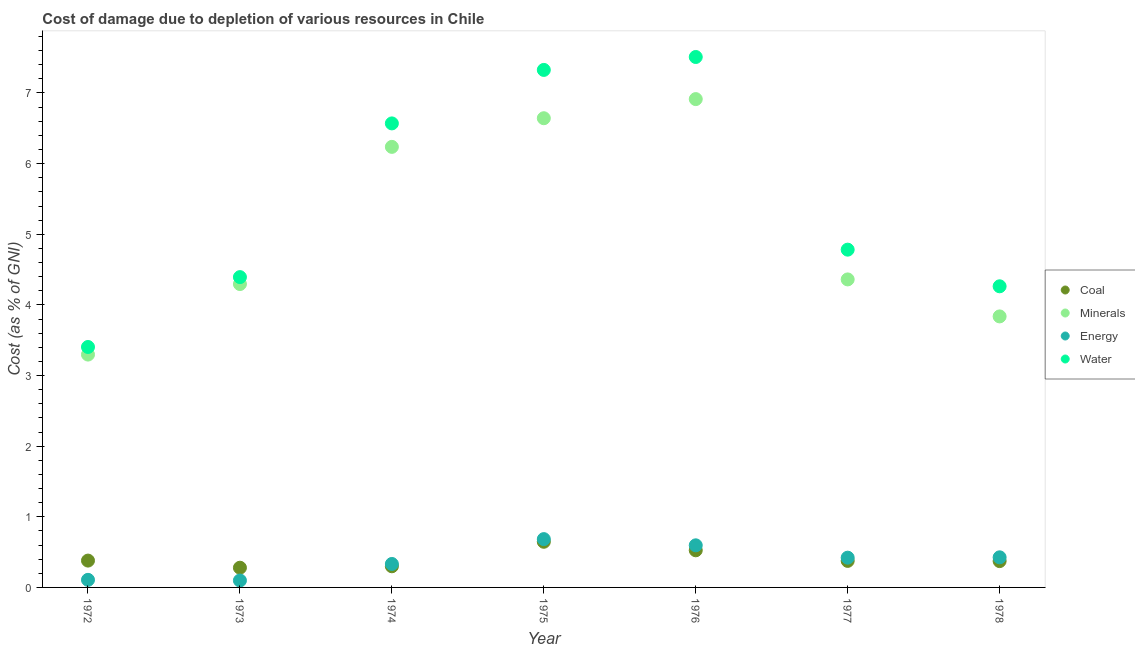How many different coloured dotlines are there?
Your answer should be very brief. 4. Is the number of dotlines equal to the number of legend labels?
Your answer should be compact. Yes. What is the cost of damage due to depletion of coal in 1972?
Provide a succinct answer. 0.38. Across all years, what is the maximum cost of damage due to depletion of coal?
Your answer should be compact. 0.65. Across all years, what is the minimum cost of damage due to depletion of energy?
Keep it short and to the point. 0.1. In which year was the cost of damage due to depletion of coal maximum?
Keep it short and to the point. 1975. In which year was the cost of damage due to depletion of energy minimum?
Keep it short and to the point. 1973. What is the total cost of damage due to depletion of coal in the graph?
Ensure brevity in your answer.  2.88. What is the difference between the cost of damage due to depletion of energy in 1973 and that in 1974?
Provide a succinct answer. -0.23. What is the difference between the cost of damage due to depletion of water in 1975 and the cost of damage due to depletion of coal in 1977?
Ensure brevity in your answer.  6.95. What is the average cost of damage due to depletion of energy per year?
Give a very brief answer. 0.38. In the year 1976, what is the difference between the cost of damage due to depletion of coal and cost of damage due to depletion of minerals?
Your answer should be very brief. -6.39. What is the ratio of the cost of damage due to depletion of coal in 1975 to that in 1978?
Your answer should be compact. 1.73. Is the cost of damage due to depletion of minerals in 1974 less than that in 1977?
Make the answer very short. No. Is the difference between the cost of damage due to depletion of minerals in 1975 and 1977 greater than the difference between the cost of damage due to depletion of water in 1975 and 1977?
Give a very brief answer. No. What is the difference between the highest and the second highest cost of damage due to depletion of energy?
Give a very brief answer. 0.09. What is the difference between the highest and the lowest cost of damage due to depletion of coal?
Provide a succinct answer. 0.37. In how many years, is the cost of damage due to depletion of water greater than the average cost of damage due to depletion of water taken over all years?
Your response must be concise. 3. Is the sum of the cost of damage due to depletion of minerals in 1974 and 1976 greater than the maximum cost of damage due to depletion of water across all years?
Provide a short and direct response. Yes. Is it the case that in every year, the sum of the cost of damage due to depletion of energy and cost of damage due to depletion of water is greater than the sum of cost of damage due to depletion of coal and cost of damage due to depletion of minerals?
Ensure brevity in your answer.  No. Is it the case that in every year, the sum of the cost of damage due to depletion of coal and cost of damage due to depletion of minerals is greater than the cost of damage due to depletion of energy?
Your answer should be very brief. Yes. Is the cost of damage due to depletion of water strictly less than the cost of damage due to depletion of coal over the years?
Keep it short and to the point. No. What is the difference between two consecutive major ticks on the Y-axis?
Offer a terse response. 1. Are the values on the major ticks of Y-axis written in scientific E-notation?
Make the answer very short. No. Does the graph contain any zero values?
Ensure brevity in your answer.  No. How are the legend labels stacked?
Your answer should be compact. Vertical. What is the title of the graph?
Provide a succinct answer. Cost of damage due to depletion of various resources in Chile . Does "Secondary general education" appear as one of the legend labels in the graph?
Keep it short and to the point. No. What is the label or title of the X-axis?
Offer a terse response. Year. What is the label or title of the Y-axis?
Your answer should be very brief. Cost (as % of GNI). What is the Cost (as % of GNI) in Coal in 1972?
Provide a short and direct response. 0.38. What is the Cost (as % of GNI) of Minerals in 1972?
Ensure brevity in your answer.  3.3. What is the Cost (as % of GNI) of Energy in 1972?
Make the answer very short. 0.11. What is the Cost (as % of GNI) of Water in 1972?
Your answer should be compact. 3.4. What is the Cost (as % of GNI) of Coal in 1973?
Give a very brief answer. 0.28. What is the Cost (as % of GNI) in Minerals in 1973?
Your response must be concise. 4.3. What is the Cost (as % of GNI) in Energy in 1973?
Give a very brief answer. 0.1. What is the Cost (as % of GNI) in Water in 1973?
Ensure brevity in your answer.  4.39. What is the Cost (as % of GNI) in Coal in 1974?
Your answer should be very brief. 0.3. What is the Cost (as % of GNI) in Minerals in 1974?
Your answer should be very brief. 6.24. What is the Cost (as % of GNI) in Energy in 1974?
Ensure brevity in your answer.  0.33. What is the Cost (as % of GNI) in Water in 1974?
Offer a very short reply. 6.57. What is the Cost (as % of GNI) of Coal in 1975?
Your response must be concise. 0.65. What is the Cost (as % of GNI) of Minerals in 1975?
Offer a very short reply. 6.64. What is the Cost (as % of GNI) of Energy in 1975?
Offer a terse response. 0.68. What is the Cost (as % of GNI) of Water in 1975?
Provide a short and direct response. 7.33. What is the Cost (as % of GNI) in Coal in 1976?
Provide a succinct answer. 0.53. What is the Cost (as % of GNI) of Minerals in 1976?
Ensure brevity in your answer.  6.91. What is the Cost (as % of GNI) in Energy in 1976?
Make the answer very short. 0.6. What is the Cost (as % of GNI) in Water in 1976?
Give a very brief answer. 7.51. What is the Cost (as % of GNI) of Coal in 1977?
Your response must be concise. 0.38. What is the Cost (as % of GNI) of Minerals in 1977?
Keep it short and to the point. 4.36. What is the Cost (as % of GNI) of Energy in 1977?
Offer a terse response. 0.42. What is the Cost (as % of GNI) in Water in 1977?
Your answer should be very brief. 4.78. What is the Cost (as % of GNI) of Coal in 1978?
Provide a succinct answer. 0.37. What is the Cost (as % of GNI) in Minerals in 1978?
Your response must be concise. 3.84. What is the Cost (as % of GNI) of Energy in 1978?
Provide a short and direct response. 0.43. What is the Cost (as % of GNI) of Water in 1978?
Your response must be concise. 4.26. Across all years, what is the maximum Cost (as % of GNI) in Coal?
Offer a very short reply. 0.65. Across all years, what is the maximum Cost (as % of GNI) in Minerals?
Offer a terse response. 6.91. Across all years, what is the maximum Cost (as % of GNI) in Energy?
Provide a succinct answer. 0.68. Across all years, what is the maximum Cost (as % of GNI) in Water?
Your answer should be compact. 7.51. Across all years, what is the minimum Cost (as % of GNI) of Coal?
Give a very brief answer. 0.28. Across all years, what is the minimum Cost (as % of GNI) in Minerals?
Offer a terse response. 3.3. Across all years, what is the minimum Cost (as % of GNI) in Energy?
Give a very brief answer. 0.1. Across all years, what is the minimum Cost (as % of GNI) of Water?
Make the answer very short. 3.4. What is the total Cost (as % of GNI) in Coal in the graph?
Keep it short and to the point. 2.88. What is the total Cost (as % of GNI) in Minerals in the graph?
Make the answer very short. 35.58. What is the total Cost (as % of GNI) of Energy in the graph?
Give a very brief answer. 2.67. What is the total Cost (as % of GNI) in Water in the graph?
Keep it short and to the point. 38.25. What is the difference between the Cost (as % of GNI) in Coal in 1972 and that in 1973?
Provide a succinct answer. 0.1. What is the difference between the Cost (as % of GNI) in Minerals in 1972 and that in 1973?
Give a very brief answer. -1. What is the difference between the Cost (as % of GNI) of Energy in 1972 and that in 1973?
Give a very brief answer. 0.01. What is the difference between the Cost (as % of GNI) of Water in 1972 and that in 1973?
Offer a terse response. -0.99. What is the difference between the Cost (as % of GNI) of Coal in 1972 and that in 1974?
Offer a very short reply. 0.08. What is the difference between the Cost (as % of GNI) of Minerals in 1972 and that in 1974?
Your response must be concise. -2.94. What is the difference between the Cost (as % of GNI) in Energy in 1972 and that in 1974?
Give a very brief answer. -0.22. What is the difference between the Cost (as % of GNI) in Water in 1972 and that in 1974?
Keep it short and to the point. -3.17. What is the difference between the Cost (as % of GNI) in Coal in 1972 and that in 1975?
Provide a short and direct response. -0.27. What is the difference between the Cost (as % of GNI) in Minerals in 1972 and that in 1975?
Your response must be concise. -3.35. What is the difference between the Cost (as % of GNI) in Energy in 1972 and that in 1975?
Your answer should be very brief. -0.58. What is the difference between the Cost (as % of GNI) of Water in 1972 and that in 1975?
Offer a very short reply. -3.92. What is the difference between the Cost (as % of GNI) of Coal in 1972 and that in 1976?
Give a very brief answer. -0.15. What is the difference between the Cost (as % of GNI) in Minerals in 1972 and that in 1976?
Offer a terse response. -3.62. What is the difference between the Cost (as % of GNI) of Energy in 1972 and that in 1976?
Provide a succinct answer. -0.49. What is the difference between the Cost (as % of GNI) of Water in 1972 and that in 1976?
Your answer should be very brief. -4.11. What is the difference between the Cost (as % of GNI) of Coal in 1972 and that in 1977?
Your response must be concise. 0. What is the difference between the Cost (as % of GNI) in Minerals in 1972 and that in 1977?
Your response must be concise. -1.06. What is the difference between the Cost (as % of GNI) of Energy in 1972 and that in 1977?
Your answer should be compact. -0.31. What is the difference between the Cost (as % of GNI) in Water in 1972 and that in 1977?
Offer a very short reply. -1.38. What is the difference between the Cost (as % of GNI) in Coal in 1972 and that in 1978?
Provide a short and direct response. 0.01. What is the difference between the Cost (as % of GNI) in Minerals in 1972 and that in 1978?
Give a very brief answer. -0.54. What is the difference between the Cost (as % of GNI) in Energy in 1972 and that in 1978?
Provide a succinct answer. -0.32. What is the difference between the Cost (as % of GNI) in Water in 1972 and that in 1978?
Offer a very short reply. -0.86. What is the difference between the Cost (as % of GNI) of Coal in 1973 and that in 1974?
Give a very brief answer. -0.02. What is the difference between the Cost (as % of GNI) of Minerals in 1973 and that in 1974?
Your answer should be compact. -1.94. What is the difference between the Cost (as % of GNI) in Energy in 1973 and that in 1974?
Provide a succinct answer. -0.23. What is the difference between the Cost (as % of GNI) in Water in 1973 and that in 1974?
Your answer should be very brief. -2.18. What is the difference between the Cost (as % of GNI) in Coal in 1973 and that in 1975?
Make the answer very short. -0.37. What is the difference between the Cost (as % of GNI) of Minerals in 1973 and that in 1975?
Your answer should be compact. -2.35. What is the difference between the Cost (as % of GNI) of Energy in 1973 and that in 1975?
Make the answer very short. -0.59. What is the difference between the Cost (as % of GNI) in Water in 1973 and that in 1975?
Your response must be concise. -2.93. What is the difference between the Cost (as % of GNI) in Coal in 1973 and that in 1976?
Provide a succinct answer. -0.25. What is the difference between the Cost (as % of GNI) in Minerals in 1973 and that in 1976?
Ensure brevity in your answer.  -2.62. What is the difference between the Cost (as % of GNI) of Energy in 1973 and that in 1976?
Provide a short and direct response. -0.5. What is the difference between the Cost (as % of GNI) in Water in 1973 and that in 1976?
Offer a very short reply. -3.12. What is the difference between the Cost (as % of GNI) of Coal in 1973 and that in 1977?
Ensure brevity in your answer.  -0.1. What is the difference between the Cost (as % of GNI) of Minerals in 1973 and that in 1977?
Ensure brevity in your answer.  -0.07. What is the difference between the Cost (as % of GNI) of Energy in 1973 and that in 1977?
Give a very brief answer. -0.32. What is the difference between the Cost (as % of GNI) in Water in 1973 and that in 1977?
Keep it short and to the point. -0.39. What is the difference between the Cost (as % of GNI) in Coal in 1973 and that in 1978?
Your answer should be very brief. -0.09. What is the difference between the Cost (as % of GNI) of Minerals in 1973 and that in 1978?
Your response must be concise. 0.46. What is the difference between the Cost (as % of GNI) in Energy in 1973 and that in 1978?
Your answer should be compact. -0.33. What is the difference between the Cost (as % of GNI) in Water in 1973 and that in 1978?
Give a very brief answer. 0.13. What is the difference between the Cost (as % of GNI) of Coal in 1974 and that in 1975?
Offer a terse response. -0.35. What is the difference between the Cost (as % of GNI) of Minerals in 1974 and that in 1975?
Keep it short and to the point. -0.41. What is the difference between the Cost (as % of GNI) of Energy in 1974 and that in 1975?
Provide a short and direct response. -0.35. What is the difference between the Cost (as % of GNI) of Water in 1974 and that in 1975?
Keep it short and to the point. -0.76. What is the difference between the Cost (as % of GNI) of Coal in 1974 and that in 1976?
Ensure brevity in your answer.  -0.23. What is the difference between the Cost (as % of GNI) of Minerals in 1974 and that in 1976?
Give a very brief answer. -0.68. What is the difference between the Cost (as % of GNI) in Energy in 1974 and that in 1976?
Ensure brevity in your answer.  -0.26. What is the difference between the Cost (as % of GNI) of Water in 1974 and that in 1976?
Keep it short and to the point. -0.94. What is the difference between the Cost (as % of GNI) of Coal in 1974 and that in 1977?
Make the answer very short. -0.08. What is the difference between the Cost (as % of GNI) in Minerals in 1974 and that in 1977?
Provide a short and direct response. 1.88. What is the difference between the Cost (as % of GNI) of Energy in 1974 and that in 1977?
Your answer should be compact. -0.09. What is the difference between the Cost (as % of GNI) in Water in 1974 and that in 1977?
Your answer should be compact. 1.79. What is the difference between the Cost (as % of GNI) of Coal in 1974 and that in 1978?
Offer a very short reply. -0.07. What is the difference between the Cost (as % of GNI) of Minerals in 1974 and that in 1978?
Ensure brevity in your answer.  2.4. What is the difference between the Cost (as % of GNI) of Energy in 1974 and that in 1978?
Your answer should be very brief. -0.09. What is the difference between the Cost (as % of GNI) in Water in 1974 and that in 1978?
Keep it short and to the point. 2.31. What is the difference between the Cost (as % of GNI) in Coal in 1975 and that in 1976?
Your answer should be compact. 0.12. What is the difference between the Cost (as % of GNI) in Minerals in 1975 and that in 1976?
Give a very brief answer. -0.27. What is the difference between the Cost (as % of GNI) in Energy in 1975 and that in 1976?
Give a very brief answer. 0.09. What is the difference between the Cost (as % of GNI) of Water in 1975 and that in 1976?
Your response must be concise. -0.18. What is the difference between the Cost (as % of GNI) of Coal in 1975 and that in 1977?
Your answer should be very brief. 0.27. What is the difference between the Cost (as % of GNI) of Minerals in 1975 and that in 1977?
Provide a succinct answer. 2.28. What is the difference between the Cost (as % of GNI) of Energy in 1975 and that in 1977?
Provide a short and direct response. 0.26. What is the difference between the Cost (as % of GNI) in Water in 1975 and that in 1977?
Make the answer very short. 2.54. What is the difference between the Cost (as % of GNI) of Coal in 1975 and that in 1978?
Offer a terse response. 0.27. What is the difference between the Cost (as % of GNI) of Minerals in 1975 and that in 1978?
Give a very brief answer. 2.81. What is the difference between the Cost (as % of GNI) of Energy in 1975 and that in 1978?
Provide a succinct answer. 0.26. What is the difference between the Cost (as % of GNI) in Water in 1975 and that in 1978?
Provide a short and direct response. 3.06. What is the difference between the Cost (as % of GNI) of Coal in 1976 and that in 1977?
Offer a terse response. 0.15. What is the difference between the Cost (as % of GNI) of Minerals in 1976 and that in 1977?
Make the answer very short. 2.55. What is the difference between the Cost (as % of GNI) in Energy in 1976 and that in 1977?
Provide a succinct answer. 0.17. What is the difference between the Cost (as % of GNI) in Water in 1976 and that in 1977?
Offer a terse response. 2.73. What is the difference between the Cost (as % of GNI) in Coal in 1976 and that in 1978?
Offer a very short reply. 0.15. What is the difference between the Cost (as % of GNI) in Minerals in 1976 and that in 1978?
Keep it short and to the point. 3.08. What is the difference between the Cost (as % of GNI) in Energy in 1976 and that in 1978?
Make the answer very short. 0.17. What is the difference between the Cost (as % of GNI) in Water in 1976 and that in 1978?
Give a very brief answer. 3.25. What is the difference between the Cost (as % of GNI) of Coal in 1977 and that in 1978?
Your answer should be compact. 0. What is the difference between the Cost (as % of GNI) of Minerals in 1977 and that in 1978?
Your answer should be compact. 0.52. What is the difference between the Cost (as % of GNI) of Energy in 1977 and that in 1978?
Your answer should be very brief. -0.01. What is the difference between the Cost (as % of GNI) of Water in 1977 and that in 1978?
Give a very brief answer. 0.52. What is the difference between the Cost (as % of GNI) of Coal in 1972 and the Cost (as % of GNI) of Minerals in 1973?
Your response must be concise. -3.92. What is the difference between the Cost (as % of GNI) of Coal in 1972 and the Cost (as % of GNI) of Energy in 1973?
Provide a succinct answer. 0.28. What is the difference between the Cost (as % of GNI) of Coal in 1972 and the Cost (as % of GNI) of Water in 1973?
Provide a succinct answer. -4.01. What is the difference between the Cost (as % of GNI) in Minerals in 1972 and the Cost (as % of GNI) in Energy in 1973?
Your answer should be compact. 3.2. What is the difference between the Cost (as % of GNI) in Minerals in 1972 and the Cost (as % of GNI) in Water in 1973?
Provide a succinct answer. -1.1. What is the difference between the Cost (as % of GNI) in Energy in 1972 and the Cost (as % of GNI) in Water in 1973?
Your answer should be compact. -4.29. What is the difference between the Cost (as % of GNI) of Coal in 1972 and the Cost (as % of GNI) of Minerals in 1974?
Your answer should be compact. -5.86. What is the difference between the Cost (as % of GNI) of Coal in 1972 and the Cost (as % of GNI) of Energy in 1974?
Ensure brevity in your answer.  0.05. What is the difference between the Cost (as % of GNI) in Coal in 1972 and the Cost (as % of GNI) in Water in 1974?
Offer a very short reply. -6.19. What is the difference between the Cost (as % of GNI) in Minerals in 1972 and the Cost (as % of GNI) in Energy in 1974?
Give a very brief answer. 2.96. What is the difference between the Cost (as % of GNI) in Minerals in 1972 and the Cost (as % of GNI) in Water in 1974?
Your response must be concise. -3.27. What is the difference between the Cost (as % of GNI) in Energy in 1972 and the Cost (as % of GNI) in Water in 1974?
Offer a terse response. -6.46. What is the difference between the Cost (as % of GNI) of Coal in 1972 and the Cost (as % of GNI) of Minerals in 1975?
Offer a very short reply. -6.26. What is the difference between the Cost (as % of GNI) in Coal in 1972 and the Cost (as % of GNI) in Energy in 1975?
Your answer should be compact. -0.3. What is the difference between the Cost (as % of GNI) in Coal in 1972 and the Cost (as % of GNI) in Water in 1975?
Your answer should be compact. -6.95. What is the difference between the Cost (as % of GNI) of Minerals in 1972 and the Cost (as % of GNI) of Energy in 1975?
Offer a very short reply. 2.61. What is the difference between the Cost (as % of GNI) in Minerals in 1972 and the Cost (as % of GNI) in Water in 1975?
Offer a very short reply. -4.03. What is the difference between the Cost (as % of GNI) in Energy in 1972 and the Cost (as % of GNI) in Water in 1975?
Offer a terse response. -7.22. What is the difference between the Cost (as % of GNI) of Coal in 1972 and the Cost (as % of GNI) of Minerals in 1976?
Keep it short and to the point. -6.53. What is the difference between the Cost (as % of GNI) of Coal in 1972 and the Cost (as % of GNI) of Energy in 1976?
Provide a short and direct response. -0.22. What is the difference between the Cost (as % of GNI) in Coal in 1972 and the Cost (as % of GNI) in Water in 1976?
Your answer should be compact. -7.13. What is the difference between the Cost (as % of GNI) in Minerals in 1972 and the Cost (as % of GNI) in Energy in 1976?
Your answer should be very brief. 2.7. What is the difference between the Cost (as % of GNI) in Minerals in 1972 and the Cost (as % of GNI) in Water in 1976?
Offer a terse response. -4.21. What is the difference between the Cost (as % of GNI) in Energy in 1972 and the Cost (as % of GNI) in Water in 1976?
Your answer should be compact. -7.4. What is the difference between the Cost (as % of GNI) in Coal in 1972 and the Cost (as % of GNI) in Minerals in 1977?
Provide a short and direct response. -3.98. What is the difference between the Cost (as % of GNI) in Coal in 1972 and the Cost (as % of GNI) in Energy in 1977?
Keep it short and to the point. -0.04. What is the difference between the Cost (as % of GNI) in Coal in 1972 and the Cost (as % of GNI) in Water in 1977?
Your response must be concise. -4.4. What is the difference between the Cost (as % of GNI) of Minerals in 1972 and the Cost (as % of GNI) of Energy in 1977?
Make the answer very short. 2.88. What is the difference between the Cost (as % of GNI) in Minerals in 1972 and the Cost (as % of GNI) in Water in 1977?
Make the answer very short. -1.49. What is the difference between the Cost (as % of GNI) of Energy in 1972 and the Cost (as % of GNI) of Water in 1977?
Keep it short and to the point. -4.67. What is the difference between the Cost (as % of GNI) in Coal in 1972 and the Cost (as % of GNI) in Minerals in 1978?
Your answer should be compact. -3.46. What is the difference between the Cost (as % of GNI) in Coal in 1972 and the Cost (as % of GNI) in Energy in 1978?
Give a very brief answer. -0.05. What is the difference between the Cost (as % of GNI) of Coal in 1972 and the Cost (as % of GNI) of Water in 1978?
Make the answer very short. -3.88. What is the difference between the Cost (as % of GNI) of Minerals in 1972 and the Cost (as % of GNI) of Energy in 1978?
Give a very brief answer. 2.87. What is the difference between the Cost (as % of GNI) in Minerals in 1972 and the Cost (as % of GNI) in Water in 1978?
Ensure brevity in your answer.  -0.97. What is the difference between the Cost (as % of GNI) in Energy in 1972 and the Cost (as % of GNI) in Water in 1978?
Your response must be concise. -4.16. What is the difference between the Cost (as % of GNI) in Coal in 1973 and the Cost (as % of GNI) in Minerals in 1974?
Make the answer very short. -5.96. What is the difference between the Cost (as % of GNI) in Coal in 1973 and the Cost (as % of GNI) in Energy in 1974?
Give a very brief answer. -0.05. What is the difference between the Cost (as % of GNI) in Coal in 1973 and the Cost (as % of GNI) in Water in 1974?
Give a very brief answer. -6.29. What is the difference between the Cost (as % of GNI) of Minerals in 1973 and the Cost (as % of GNI) of Energy in 1974?
Your answer should be compact. 3.96. What is the difference between the Cost (as % of GNI) in Minerals in 1973 and the Cost (as % of GNI) in Water in 1974?
Your answer should be compact. -2.27. What is the difference between the Cost (as % of GNI) of Energy in 1973 and the Cost (as % of GNI) of Water in 1974?
Offer a terse response. -6.47. What is the difference between the Cost (as % of GNI) of Coal in 1973 and the Cost (as % of GNI) of Minerals in 1975?
Give a very brief answer. -6.36. What is the difference between the Cost (as % of GNI) of Coal in 1973 and the Cost (as % of GNI) of Energy in 1975?
Your answer should be compact. -0.4. What is the difference between the Cost (as % of GNI) in Coal in 1973 and the Cost (as % of GNI) in Water in 1975?
Keep it short and to the point. -7.05. What is the difference between the Cost (as % of GNI) in Minerals in 1973 and the Cost (as % of GNI) in Energy in 1975?
Keep it short and to the point. 3.61. What is the difference between the Cost (as % of GNI) of Minerals in 1973 and the Cost (as % of GNI) of Water in 1975?
Your response must be concise. -3.03. What is the difference between the Cost (as % of GNI) of Energy in 1973 and the Cost (as % of GNI) of Water in 1975?
Make the answer very short. -7.23. What is the difference between the Cost (as % of GNI) of Coal in 1973 and the Cost (as % of GNI) of Minerals in 1976?
Make the answer very short. -6.63. What is the difference between the Cost (as % of GNI) in Coal in 1973 and the Cost (as % of GNI) in Energy in 1976?
Offer a terse response. -0.32. What is the difference between the Cost (as % of GNI) in Coal in 1973 and the Cost (as % of GNI) in Water in 1976?
Provide a succinct answer. -7.23. What is the difference between the Cost (as % of GNI) in Minerals in 1973 and the Cost (as % of GNI) in Energy in 1976?
Your answer should be very brief. 3.7. What is the difference between the Cost (as % of GNI) of Minerals in 1973 and the Cost (as % of GNI) of Water in 1976?
Your response must be concise. -3.21. What is the difference between the Cost (as % of GNI) of Energy in 1973 and the Cost (as % of GNI) of Water in 1976?
Offer a terse response. -7.41. What is the difference between the Cost (as % of GNI) of Coal in 1973 and the Cost (as % of GNI) of Minerals in 1977?
Provide a short and direct response. -4.08. What is the difference between the Cost (as % of GNI) in Coal in 1973 and the Cost (as % of GNI) in Energy in 1977?
Offer a very short reply. -0.14. What is the difference between the Cost (as % of GNI) in Coal in 1973 and the Cost (as % of GNI) in Water in 1977?
Keep it short and to the point. -4.5. What is the difference between the Cost (as % of GNI) of Minerals in 1973 and the Cost (as % of GNI) of Energy in 1977?
Keep it short and to the point. 3.87. What is the difference between the Cost (as % of GNI) of Minerals in 1973 and the Cost (as % of GNI) of Water in 1977?
Your response must be concise. -0.49. What is the difference between the Cost (as % of GNI) of Energy in 1973 and the Cost (as % of GNI) of Water in 1977?
Offer a terse response. -4.68. What is the difference between the Cost (as % of GNI) in Coal in 1973 and the Cost (as % of GNI) in Minerals in 1978?
Keep it short and to the point. -3.56. What is the difference between the Cost (as % of GNI) of Coal in 1973 and the Cost (as % of GNI) of Energy in 1978?
Give a very brief answer. -0.15. What is the difference between the Cost (as % of GNI) of Coal in 1973 and the Cost (as % of GNI) of Water in 1978?
Offer a very short reply. -3.98. What is the difference between the Cost (as % of GNI) of Minerals in 1973 and the Cost (as % of GNI) of Energy in 1978?
Your response must be concise. 3.87. What is the difference between the Cost (as % of GNI) in Minerals in 1973 and the Cost (as % of GNI) in Water in 1978?
Provide a succinct answer. 0.03. What is the difference between the Cost (as % of GNI) of Energy in 1973 and the Cost (as % of GNI) of Water in 1978?
Provide a succinct answer. -4.17. What is the difference between the Cost (as % of GNI) of Coal in 1974 and the Cost (as % of GNI) of Minerals in 1975?
Keep it short and to the point. -6.34. What is the difference between the Cost (as % of GNI) of Coal in 1974 and the Cost (as % of GNI) of Energy in 1975?
Keep it short and to the point. -0.38. What is the difference between the Cost (as % of GNI) of Coal in 1974 and the Cost (as % of GNI) of Water in 1975?
Provide a short and direct response. -7.03. What is the difference between the Cost (as % of GNI) of Minerals in 1974 and the Cost (as % of GNI) of Energy in 1975?
Ensure brevity in your answer.  5.55. What is the difference between the Cost (as % of GNI) in Minerals in 1974 and the Cost (as % of GNI) in Water in 1975?
Provide a succinct answer. -1.09. What is the difference between the Cost (as % of GNI) of Energy in 1974 and the Cost (as % of GNI) of Water in 1975?
Give a very brief answer. -6.99. What is the difference between the Cost (as % of GNI) in Coal in 1974 and the Cost (as % of GNI) in Minerals in 1976?
Provide a short and direct response. -6.61. What is the difference between the Cost (as % of GNI) of Coal in 1974 and the Cost (as % of GNI) of Energy in 1976?
Your answer should be very brief. -0.3. What is the difference between the Cost (as % of GNI) in Coal in 1974 and the Cost (as % of GNI) in Water in 1976?
Your response must be concise. -7.21. What is the difference between the Cost (as % of GNI) of Minerals in 1974 and the Cost (as % of GNI) of Energy in 1976?
Offer a terse response. 5.64. What is the difference between the Cost (as % of GNI) of Minerals in 1974 and the Cost (as % of GNI) of Water in 1976?
Keep it short and to the point. -1.27. What is the difference between the Cost (as % of GNI) in Energy in 1974 and the Cost (as % of GNI) in Water in 1976?
Your response must be concise. -7.18. What is the difference between the Cost (as % of GNI) in Coal in 1974 and the Cost (as % of GNI) in Minerals in 1977?
Give a very brief answer. -4.06. What is the difference between the Cost (as % of GNI) in Coal in 1974 and the Cost (as % of GNI) in Energy in 1977?
Ensure brevity in your answer.  -0.12. What is the difference between the Cost (as % of GNI) in Coal in 1974 and the Cost (as % of GNI) in Water in 1977?
Ensure brevity in your answer.  -4.48. What is the difference between the Cost (as % of GNI) in Minerals in 1974 and the Cost (as % of GNI) in Energy in 1977?
Make the answer very short. 5.82. What is the difference between the Cost (as % of GNI) in Minerals in 1974 and the Cost (as % of GNI) in Water in 1977?
Your answer should be compact. 1.46. What is the difference between the Cost (as % of GNI) in Energy in 1974 and the Cost (as % of GNI) in Water in 1977?
Offer a very short reply. -4.45. What is the difference between the Cost (as % of GNI) in Coal in 1974 and the Cost (as % of GNI) in Minerals in 1978?
Provide a short and direct response. -3.54. What is the difference between the Cost (as % of GNI) of Coal in 1974 and the Cost (as % of GNI) of Energy in 1978?
Keep it short and to the point. -0.13. What is the difference between the Cost (as % of GNI) of Coal in 1974 and the Cost (as % of GNI) of Water in 1978?
Keep it short and to the point. -3.96. What is the difference between the Cost (as % of GNI) of Minerals in 1974 and the Cost (as % of GNI) of Energy in 1978?
Give a very brief answer. 5.81. What is the difference between the Cost (as % of GNI) in Minerals in 1974 and the Cost (as % of GNI) in Water in 1978?
Provide a short and direct response. 1.97. What is the difference between the Cost (as % of GNI) of Energy in 1974 and the Cost (as % of GNI) of Water in 1978?
Ensure brevity in your answer.  -3.93. What is the difference between the Cost (as % of GNI) in Coal in 1975 and the Cost (as % of GNI) in Minerals in 1976?
Give a very brief answer. -6.27. What is the difference between the Cost (as % of GNI) in Coal in 1975 and the Cost (as % of GNI) in Energy in 1976?
Your answer should be very brief. 0.05. What is the difference between the Cost (as % of GNI) in Coal in 1975 and the Cost (as % of GNI) in Water in 1976?
Your answer should be compact. -6.86. What is the difference between the Cost (as % of GNI) of Minerals in 1975 and the Cost (as % of GNI) of Energy in 1976?
Give a very brief answer. 6.05. What is the difference between the Cost (as % of GNI) in Minerals in 1975 and the Cost (as % of GNI) in Water in 1976?
Offer a very short reply. -0.87. What is the difference between the Cost (as % of GNI) in Energy in 1975 and the Cost (as % of GNI) in Water in 1976?
Offer a very short reply. -6.83. What is the difference between the Cost (as % of GNI) in Coal in 1975 and the Cost (as % of GNI) in Minerals in 1977?
Provide a succinct answer. -3.71. What is the difference between the Cost (as % of GNI) of Coal in 1975 and the Cost (as % of GNI) of Energy in 1977?
Provide a short and direct response. 0.22. What is the difference between the Cost (as % of GNI) in Coal in 1975 and the Cost (as % of GNI) in Water in 1977?
Offer a terse response. -4.14. What is the difference between the Cost (as % of GNI) in Minerals in 1975 and the Cost (as % of GNI) in Energy in 1977?
Your answer should be compact. 6.22. What is the difference between the Cost (as % of GNI) of Minerals in 1975 and the Cost (as % of GNI) of Water in 1977?
Offer a terse response. 1.86. What is the difference between the Cost (as % of GNI) of Energy in 1975 and the Cost (as % of GNI) of Water in 1977?
Make the answer very short. -4.1. What is the difference between the Cost (as % of GNI) in Coal in 1975 and the Cost (as % of GNI) in Minerals in 1978?
Give a very brief answer. -3.19. What is the difference between the Cost (as % of GNI) in Coal in 1975 and the Cost (as % of GNI) in Energy in 1978?
Ensure brevity in your answer.  0.22. What is the difference between the Cost (as % of GNI) in Coal in 1975 and the Cost (as % of GNI) in Water in 1978?
Provide a succinct answer. -3.62. What is the difference between the Cost (as % of GNI) in Minerals in 1975 and the Cost (as % of GNI) in Energy in 1978?
Offer a very short reply. 6.22. What is the difference between the Cost (as % of GNI) in Minerals in 1975 and the Cost (as % of GNI) in Water in 1978?
Make the answer very short. 2.38. What is the difference between the Cost (as % of GNI) in Energy in 1975 and the Cost (as % of GNI) in Water in 1978?
Provide a succinct answer. -3.58. What is the difference between the Cost (as % of GNI) of Coal in 1976 and the Cost (as % of GNI) of Minerals in 1977?
Provide a succinct answer. -3.83. What is the difference between the Cost (as % of GNI) in Coal in 1976 and the Cost (as % of GNI) in Energy in 1977?
Your answer should be compact. 0.1. What is the difference between the Cost (as % of GNI) of Coal in 1976 and the Cost (as % of GNI) of Water in 1977?
Ensure brevity in your answer.  -4.26. What is the difference between the Cost (as % of GNI) of Minerals in 1976 and the Cost (as % of GNI) of Energy in 1977?
Make the answer very short. 6.49. What is the difference between the Cost (as % of GNI) in Minerals in 1976 and the Cost (as % of GNI) in Water in 1977?
Ensure brevity in your answer.  2.13. What is the difference between the Cost (as % of GNI) of Energy in 1976 and the Cost (as % of GNI) of Water in 1977?
Offer a terse response. -4.19. What is the difference between the Cost (as % of GNI) of Coal in 1976 and the Cost (as % of GNI) of Minerals in 1978?
Make the answer very short. -3.31. What is the difference between the Cost (as % of GNI) in Coal in 1976 and the Cost (as % of GNI) in Energy in 1978?
Provide a succinct answer. 0.1. What is the difference between the Cost (as % of GNI) of Coal in 1976 and the Cost (as % of GNI) of Water in 1978?
Provide a short and direct response. -3.74. What is the difference between the Cost (as % of GNI) of Minerals in 1976 and the Cost (as % of GNI) of Energy in 1978?
Your response must be concise. 6.49. What is the difference between the Cost (as % of GNI) of Minerals in 1976 and the Cost (as % of GNI) of Water in 1978?
Give a very brief answer. 2.65. What is the difference between the Cost (as % of GNI) of Energy in 1976 and the Cost (as % of GNI) of Water in 1978?
Your answer should be very brief. -3.67. What is the difference between the Cost (as % of GNI) of Coal in 1977 and the Cost (as % of GNI) of Minerals in 1978?
Make the answer very short. -3.46. What is the difference between the Cost (as % of GNI) in Coal in 1977 and the Cost (as % of GNI) in Energy in 1978?
Make the answer very short. -0.05. What is the difference between the Cost (as % of GNI) of Coal in 1977 and the Cost (as % of GNI) of Water in 1978?
Your answer should be very brief. -3.89. What is the difference between the Cost (as % of GNI) in Minerals in 1977 and the Cost (as % of GNI) in Energy in 1978?
Your answer should be very brief. 3.93. What is the difference between the Cost (as % of GNI) in Minerals in 1977 and the Cost (as % of GNI) in Water in 1978?
Provide a succinct answer. 0.1. What is the difference between the Cost (as % of GNI) in Energy in 1977 and the Cost (as % of GNI) in Water in 1978?
Provide a short and direct response. -3.84. What is the average Cost (as % of GNI) of Coal per year?
Provide a short and direct response. 0.41. What is the average Cost (as % of GNI) in Minerals per year?
Your answer should be very brief. 5.08. What is the average Cost (as % of GNI) in Energy per year?
Make the answer very short. 0.38. What is the average Cost (as % of GNI) in Water per year?
Your answer should be very brief. 5.46. In the year 1972, what is the difference between the Cost (as % of GNI) of Coal and Cost (as % of GNI) of Minerals?
Your answer should be compact. -2.92. In the year 1972, what is the difference between the Cost (as % of GNI) in Coal and Cost (as % of GNI) in Energy?
Offer a terse response. 0.27. In the year 1972, what is the difference between the Cost (as % of GNI) in Coal and Cost (as % of GNI) in Water?
Provide a succinct answer. -3.02. In the year 1972, what is the difference between the Cost (as % of GNI) in Minerals and Cost (as % of GNI) in Energy?
Provide a short and direct response. 3.19. In the year 1972, what is the difference between the Cost (as % of GNI) of Minerals and Cost (as % of GNI) of Water?
Provide a succinct answer. -0.11. In the year 1972, what is the difference between the Cost (as % of GNI) of Energy and Cost (as % of GNI) of Water?
Your response must be concise. -3.3. In the year 1973, what is the difference between the Cost (as % of GNI) in Coal and Cost (as % of GNI) in Minerals?
Your answer should be very brief. -4.02. In the year 1973, what is the difference between the Cost (as % of GNI) in Coal and Cost (as % of GNI) in Energy?
Give a very brief answer. 0.18. In the year 1973, what is the difference between the Cost (as % of GNI) in Coal and Cost (as % of GNI) in Water?
Ensure brevity in your answer.  -4.11. In the year 1973, what is the difference between the Cost (as % of GNI) in Minerals and Cost (as % of GNI) in Energy?
Your answer should be very brief. 4.2. In the year 1973, what is the difference between the Cost (as % of GNI) of Minerals and Cost (as % of GNI) of Water?
Offer a very short reply. -0.1. In the year 1973, what is the difference between the Cost (as % of GNI) in Energy and Cost (as % of GNI) in Water?
Your answer should be very brief. -4.3. In the year 1974, what is the difference between the Cost (as % of GNI) of Coal and Cost (as % of GNI) of Minerals?
Ensure brevity in your answer.  -5.94. In the year 1974, what is the difference between the Cost (as % of GNI) in Coal and Cost (as % of GNI) in Energy?
Provide a succinct answer. -0.03. In the year 1974, what is the difference between the Cost (as % of GNI) in Coal and Cost (as % of GNI) in Water?
Your answer should be compact. -6.27. In the year 1974, what is the difference between the Cost (as % of GNI) of Minerals and Cost (as % of GNI) of Energy?
Give a very brief answer. 5.9. In the year 1974, what is the difference between the Cost (as % of GNI) of Minerals and Cost (as % of GNI) of Water?
Give a very brief answer. -0.33. In the year 1974, what is the difference between the Cost (as % of GNI) of Energy and Cost (as % of GNI) of Water?
Give a very brief answer. -6.24. In the year 1975, what is the difference between the Cost (as % of GNI) of Coal and Cost (as % of GNI) of Minerals?
Make the answer very short. -6. In the year 1975, what is the difference between the Cost (as % of GNI) of Coal and Cost (as % of GNI) of Energy?
Offer a very short reply. -0.04. In the year 1975, what is the difference between the Cost (as % of GNI) in Coal and Cost (as % of GNI) in Water?
Ensure brevity in your answer.  -6.68. In the year 1975, what is the difference between the Cost (as % of GNI) in Minerals and Cost (as % of GNI) in Energy?
Keep it short and to the point. 5.96. In the year 1975, what is the difference between the Cost (as % of GNI) of Minerals and Cost (as % of GNI) of Water?
Your answer should be very brief. -0.68. In the year 1975, what is the difference between the Cost (as % of GNI) of Energy and Cost (as % of GNI) of Water?
Your response must be concise. -6.64. In the year 1976, what is the difference between the Cost (as % of GNI) of Coal and Cost (as % of GNI) of Minerals?
Provide a short and direct response. -6.39. In the year 1976, what is the difference between the Cost (as % of GNI) of Coal and Cost (as % of GNI) of Energy?
Your answer should be compact. -0.07. In the year 1976, what is the difference between the Cost (as % of GNI) in Coal and Cost (as % of GNI) in Water?
Keep it short and to the point. -6.98. In the year 1976, what is the difference between the Cost (as % of GNI) in Minerals and Cost (as % of GNI) in Energy?
Offer a very short reply. 6.32. In the year 1976, what is the difference between the Cost (as % of GNI) of Minerals and Cost (as % of GNI) of Water?
Provide a succinct answer. -0.6. In the year 1976, what is the difference between the Cost (as % of GNI) in Energy and Cost (as % of GNI) in Water?
Make the answer very short. -6.91. In the year 1977, what is the difference between the Cost (as % of GNI) of Coal and Cost (as % of GNI) of Minerals?
Keep it short and to the point. -3.98. In the year 1977, what is the difference between the Cost (as % of GNI) of Coal and Cost (as % of GNI) of Energy?
Provide a short and direct response. -0.05. In the year 1977, what is the difference between the Cost (as % of GNI) of Coal and Cost (as % of GNI) of Water?
Ensure brevity in your answer.  -4.41. In the year 1977, what is the difference between the Cost (as % of GNI) in Minerals and Cost (as % of GNI) in Energy?
Ensure brevity in your answer.  3.94. In the year 1977, what is the difference between the Cost (as % of GNI) of Minerals and Cost (as % of GNI) of Water?
Your answer should be compact. -0.42. In the year 1977, what is the difference between the Cost (as % of GNI) in Energy and Cost (as % of GNI) in Water?
Provide a succinct answer. -4.36. In the year 1978, what is the difference between the Cost (as % of GNI) of Coal and Cost (as % of GNI) of Minerals?
Provide a short and direct response. -3.46. In the year 1978, what is the difference between the Cost (as % of GNI) of Coal and Cost (as % of GNI) of Energy?
Offer a very short reply. -0.05. In the year 1978, what is the difference between the Cost (as % of GNI) of Coal and Cost (as % of GNI) of Water?
Your answer should be very brief. -3.89. In the year 1978, what is the difference between the Cost (as % of GNI) of Minerals and Cost (as % of GNI) of Energy?
Your response must be concise. 3.41. In the year 1978, what is the difference between the Cost (as % of GNI) of Minerals and Cost (as % of GNI) of Water?
Offer a very short reply. -0.43. In the year 1978, what is the difference between the Cost (as % of GNI) of Energy and Cost (as % of GNI) of Water?
Provide a short and direct response. -3.84. What is the ratio of the Cost (as % of GNI) in Coal in 1972 to that in 1973?
Make the answer very short. 1.36. What is the ratio of the Cost (as % of GNI) of Minerals in 1972 to that in 1973?
Your answer should be very brief. 0.77. What is the ratio of the Cost (as % of GNI) of Energy in 1972 to that in 1973?
Ensure brevity in your answer.  1.09. What is the ratio of the Cost (as % of GNI) in Water in 1972 to that in 1973?
Provide a short and direct response. 0.77. What is the ratio of the Cost (as % of GNI) in Coal in 1972 to that in 1974?
Keep it short and to the point. 1.27. What is the ratio of the Cost (as % of GNI) of Minerals in 1972 to that in 1974?
Ensure brevity in your answer.  0.53. What is the ratio of the Cost (as % of GNI) of Energy in 1972 to that in 1974?
Keep it short and to the point. 0.32. What is the ratio of the Cost (as % of GNI) of Water in 1972 to that in 1974?
Offer a terse response. 0.52. What is the ratio of the Cost (as % of GNI) in Coal in 1972 to that in 1975?
Ensure brevity in your answer.  0.59. What is the ratio of the Cost (as % of GNI) of Minerals in 1972 to that in 1975?
Your answer should be very brief. 0.5. What is the ratio of the Cost (as % of GNI) in Energy in 1972 to that in 1975?
Provide a succinct answer. 0.16. What is the ratio of the Cost (as % of GNI) of Water in 1972 to that in 1975?
Your response must be concise. 0.46. What is the ratio of the Cost (as % of GNI) in Coal in 1972 to that in 1976?
Your answer should be very brief. 0.72. What is the ratio of the Cost (as % of GNI) in Minerals in 1972 to that in 1976?
Give a very brief answer. 0.48. What is the ratio of the Cost (as % of GNI) of Energy in 1972 to that in 1976?
Ensure brevity in your answer.  0.18. What is the ratio of the Cost (as % of GNI) of Water in 1972 to that in 1976?
Keep it short and to the point. 0.45. What is the ratio of the Cost (as % of GNI) in Coal in 1972 to that in 1977?
Your answer should be very brief. 1.01. What is the ratio of the Cost (as % of GNI) of Minerals in 1972 to that in 1977?
Make the answer very short. 0.76. What is the ratio of the Cost (as % of GNI) of Energy in 1972 to that in 1977?
Keep it short and to the point. 0.25. What is the ratio of the Cost (as % of GNI) in Water in 1972 to that in 1977?
Offer a very short reply. 0.71. What is the ratio of the Cost (as % of GNI) in Coal in 1972 to that in 1978?
Offer a terse response. 1.02. What is the ratio of the Cost (as % of GNI) of Minerals in 1972 to that in 1978?
Keep it short and to the point. 0.86. What is the ratio of the Cost (as % of GNI) in Energy in 1972 to that in 1978?
Your answer should be very brief. 0.25. What is the ratio of the Cost (as % of GNI) in Water in 1972 to that in 1978?
Give a very brief answer. 0.8. What is the ratio of the Cost (as % of GNI) in Coal in 1973 to that in 1974?
Provide a succinct answer. 0.93. What is the ratio of the Cost (as % of GNI) of Minerals in 1973 to that in 1974?
Make the answer very short. 0.69. What is the ratio of the Cost (as % of GNI) of Energy in 1973 to that in 1974?
Provide a succinct answer. 0.3. What is the ratio of the Cost (as % of GNI) in Water in 1973 to that in 1974?
Give a very brief answer. 0.67. What is the ratio of the Cost (as % of GNI) in Coal in 1973 to that in 1975?
Give a very brief answer. 0.43. What is the ratio of the Cost (as % of GNI) of Minerals in 1973 to that in 1975?
Keep it short and to the point. 0.65. What is the ratio of the Cost (as % of GNI) in Energy in 1973 to that in 1975?
Provide a short and direct response. 0.14. What is the ratio of the Cost (as % of GNI) of Water in 1973 to that in 1975?
Provide a succinct answer. 0.6. What is the ratio of the Cost (as % of GNI) of Coal in 1973 to that in 1976?
Provide a short and direct response. 0.53. What is the ratio of the Cost (as % of GNI) in Minerals in 1973 to that in 1976?
Your response must be concise. 0.62. What is the ratio of the Cost (as % of GNI) in Energy in 1973 to that in 1976?
Offer a very short reply. 0.16. What is the ratio of the Cost (as % of GNI) of Water in 1973 to that in 1976?
Your response must be concise. 0.58. What is the ratio of the Cost (as % of GNI) of Coal in 1973 to that in 1977?
Offer a very short reply. 0.74. What is the ratio of the Cost (as % of GNI) of Energy in 1973 to that in 1977?
Offer a very short reply. 0.23. What is the ratio of the Cost (as % of GNI) of Water in 1973 to that in 1977?
Make the answer very short. 0.92. What is the ratio of the Cost (as % of GNI) in Coal in 1973 to that in 1978?
Your response must be concise. 0.75. What is the ratio of the Cost (as % of GNI) in Minerals in 1973 to that in 1978?
Keep it short and to the point. 1.12. What is the ratio of the Cost (as % of GNI) of Energy in 1973 to that in 1978?
Make the answer very short. 0.23. What is the ratio of the Cost (as % of GNI) of Water in 1973 to that in 1978?
Keep it short and to the point. 1.03. What is the ratio of the Cost (as % of GNI) of Coal in 1974 to that in 1975?
Keep it short and to the point. 0.46. What is the ratio of the Cost (as % of GNI) in Minerals in 1974 to that in 1975?
Ensure brevity in your answer.  0.94. What is the ratio of the Cost (as % of GNI) of Energy in 1974 to that in 1975?
Make the answer very short. 0.49. What is the ratio of the Cost (as % of GNI) in Water in 1974 to that in 1975?
Offer a very short reply. 0.9. What is the ratio of the Cost (as % of GNI) of Coal in 1974 to that in 1976?
Ensure brevity in your answer.  0.57. What is the ratio of the Cost (as % of GNI) of Minerals in 1974 to that in 1976?
Offer a terse response. 0.9. What is the ratio of the Cost (as % of GNI) in Energy in 1974 to that in 1976?
Keep it short and to the point. 0.56. What is the ratio of the Cost (as % of GNI) of Water in 1974 to that in 1976?
Your response must be concise. 0.87. What is the ratio of the Cost (as % of GNI) of Coal in 1974 to that in 1977?
Provide a succinct answer. 0.8. What is the ratio of the Cost (as % of GNI) in Minerals in 1974 to that in 1977?
Your answer should be compact. 1.43. What is the ratio of the Cost (as % of GNI) in Energy in 1974 to that in 1977?
Offer a terse response. 0.79. What is the ratio of the Cost (as % of GNI) in Water in 1974 to that in 1977?
Provide a succinct answer. 1.37. What is the ratio of the Cost (as % of GNI) of Coal in 1974 to that in 1978?
Your answer should be very brief. 0.8. What is the ratio of the Cost (as % of GNI) of Minerals in 1974 to that in 1978?
Give a very brief answer. 1.63. What is the ratio of the Cost (as % of GNI) of Energy in 1974 to that in 1978?
Ensure brevity in your answer.  0.78. What is the ratio of the Cost (as % of GNI) in Water in 1974 to that in 1978?
Provide a succinct answer. 1.54. What is the ratio of the Cost (as % of GNI) of Coal in 1975 to that in 1976?
Your answer should be very brief. 1.23. What is the ratio of the Cost (as % of GNI) of Minerals in 1975 to that in 1976?
Your answer should be compact. 0.96. What is the ratio of the Cost (as % of GNI) in Energy in 1975 to that in 1976?
Give a very brief answer. 1.15. What is the ratio of the Cost (as % of GNI) of Water in 1975 to that in 1976?
Offer a terse response. 0.98. What is the ratio of the Cost (as % of GNI) of Coal in 1975 to that in 1977?
Your response must be concise. 1.72. What is the ratio of the Cost (as % of GNI) in Minerals in 1975 to that in 1977?
Make the answer very short. 1.52. What is the ratio of the Cost (as % of GNI) of Energy in 1975 to that in 1977?
Provide a succinct answer. 1.62. What is the ratio of the Cost (as % of GNI) of Water in 1975 to that in 1977?
Give a very brief answer. 1.53. What is the ratio of the Cost (as % of GNI) of Coal in 1975 to that in 1978?
Give a very brief answer. 1.73. What is the ratio of the Cost (as % of GNI) of Minerals in 1975 to that in 1978?
Your answer should be compact. 1.73. What is the ratio of the Cost (as % of GNI) in Energy in 1975 to that in 1978?
Offer a very short reply. 1.6. What is the ratio of the Cost (as % of GNI) in Water in 1975 to that in 1978?
Offer a terse response. 1.72. What is the ratio of the Cost (as % of GNI) in Coal in 1976 to that in 1977?
Provide a short and direct response. 1.4. What is the ratio of the Cost (as % of GNI) in Minerals in 1976 to that in 1977?
Ensure brevity in your answer.  1.59. What is the ratio of the Cost (as % of GNI) in Energy in 1976 to that in 1977?
Offer a terse response. 1.41. What is the ratio of the Cost (as % of GNI) of Water in 1976 to that in 1977?
Offer a terse response. 1.57. What is the ratio of the Cost (as % of GNI) of Coal in 1976 to that in 1978?
Offer a very short reply. 1.41. What is the ratio of the Cost (as % of GNI) in Minerals in 1976 to that in 1978?
Offer a terse response. 1.8. What is the ratio of the Cost (as % of GNI) of Energy in 1976 to that in 1978?
Keep it short and to the point. 1.4. What is the ratio of the Cost (as % of GNI) in Water in 1976 to that in 1978?
Provide a short and direct response. 1.76. What is the ratio of the Cost (as % of GNI) in Coal in 1977 to that in 1978?
Keep it short and to the point. 1.01. What is the ratio of the Cost (as % of GNI) of Minerals in 1977 to that in 1978?
Ensure brevity in your answer.  1.14. What is the ratio of the Cost (as % of GNI) of Energy in 1977 to that in 1978?
Give a very brief answer. 0.99. What is the ratio of the Cost (as % of GNI) in Water in 1977 to that in 1978?
Your response must be concise. 1.12. What is the difference between the highest and the second highest Cost (as % of GNI) of Coal?
Ensure brevity in your answer.  0.12. What is the difference between the highest and the second highest Cost (as % of GNI) of Minerals?
Provide a succinct answer. 0.27. What is the difference between the highest and the second highest Cost (as % of GNI) in Energy?
Offer a very short reply. 0.09. What is the difference between the highest and the second highest Cost (as % of GNI) in Water?
Provide a short and direct response. 0.18. What is the difference between the highest and the lowest Cost (as % of GNI) in Coal?
Offer a terse response. 0.37. What is the difference between the highest and the lowest Cost (as % of GNI) of Minerals?
Your answer should be compact. 3.62. What is the difference between the highest and the lowest Cost (as % of GNI) in Energy?
Your answer should be very brief. 0.59. What is the difference between the highest and the lowest Cost (as % of GNI) of Water?
Provide a short and direct response. 4.11. 